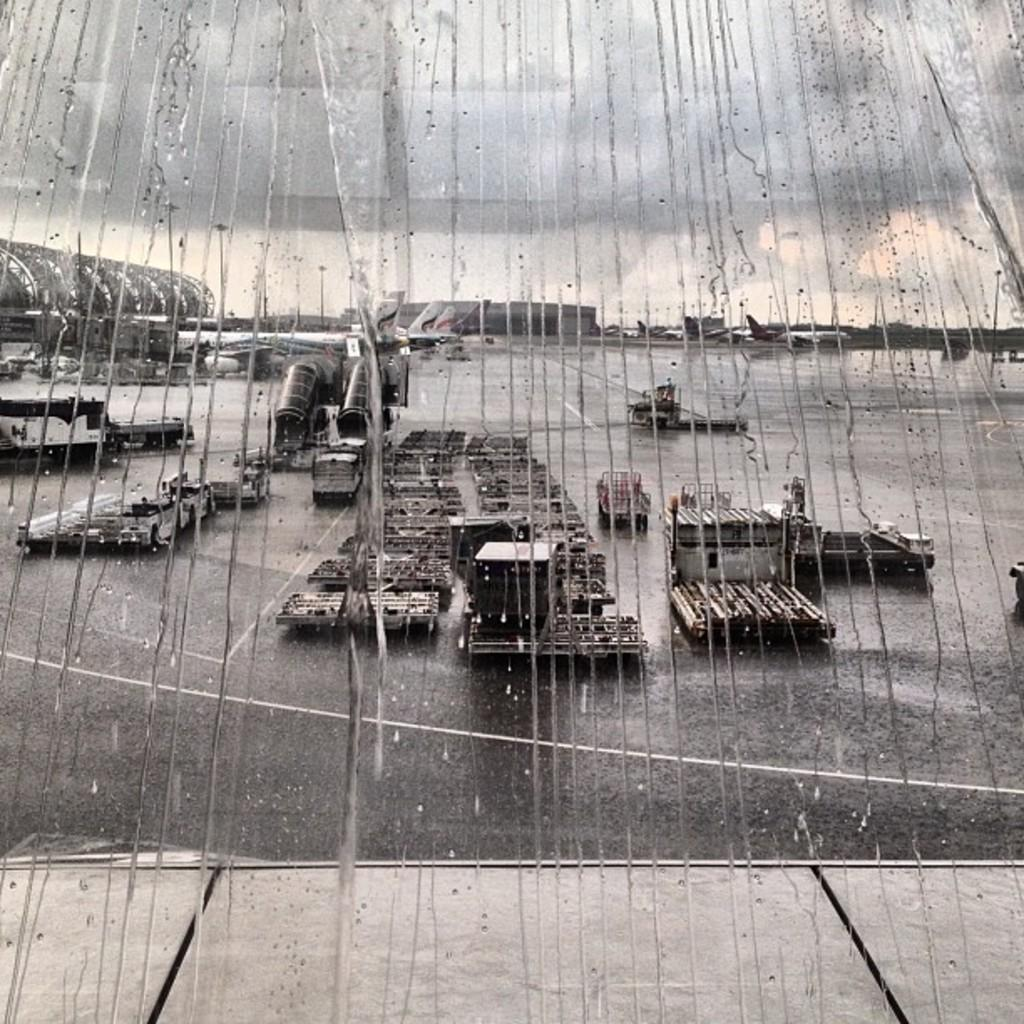What is happening to the glass window in the image? It is raining on the glass window in the image. What type of location does the image appear to depict? The image appears to depict an airport. How many kittens are playing with snakes on the airport runway in the image? There are no kittens or snakes present in the image; it only shows rain on a glass window and the airport setting. 